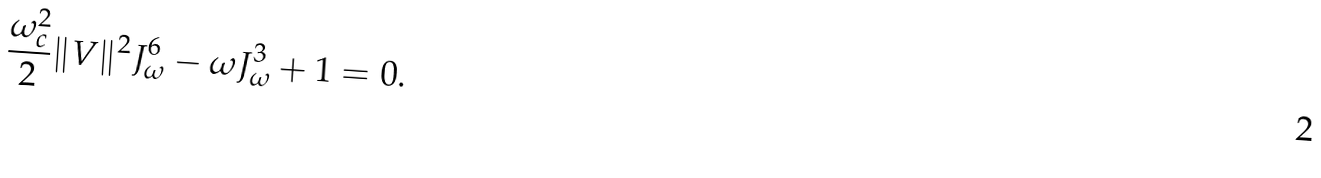<formula> <loc_0><loc_0><loc_500><loc_500>\frac { \omega _ { c } ^ { 2 } } { 2 } \| V \| ^ { 2 } J _ { \omega } ^ { 6 } - \omega J ^ { 3 } _ { \omega } + 1 = 0 .</formula> 